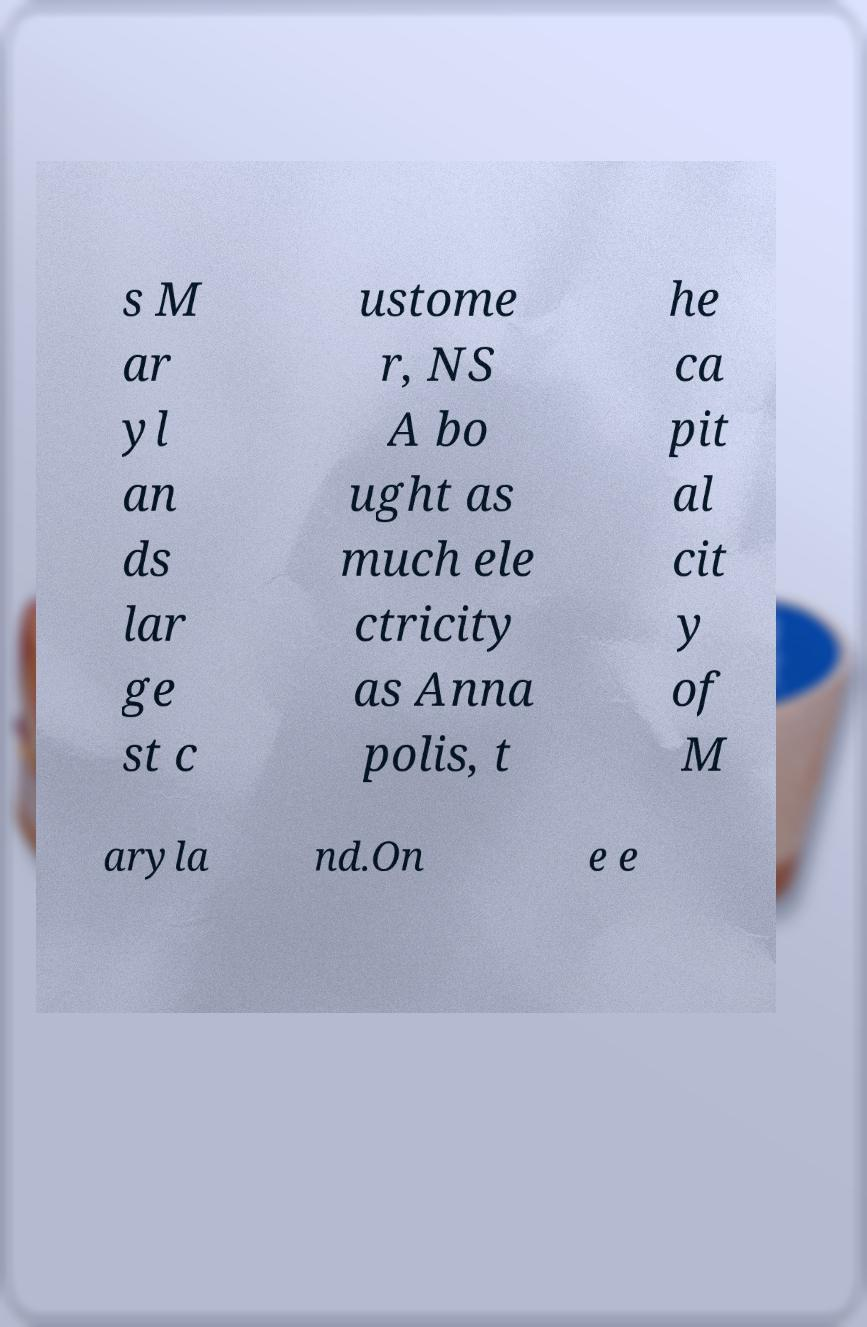Please identify and transcribe the text found in this image. s M ar yl an ds lar ge st c ustome r, NS A bo ught as much ele ctricity as Anna polis, t he ca pit al cit y of M aryla nd.On e e 